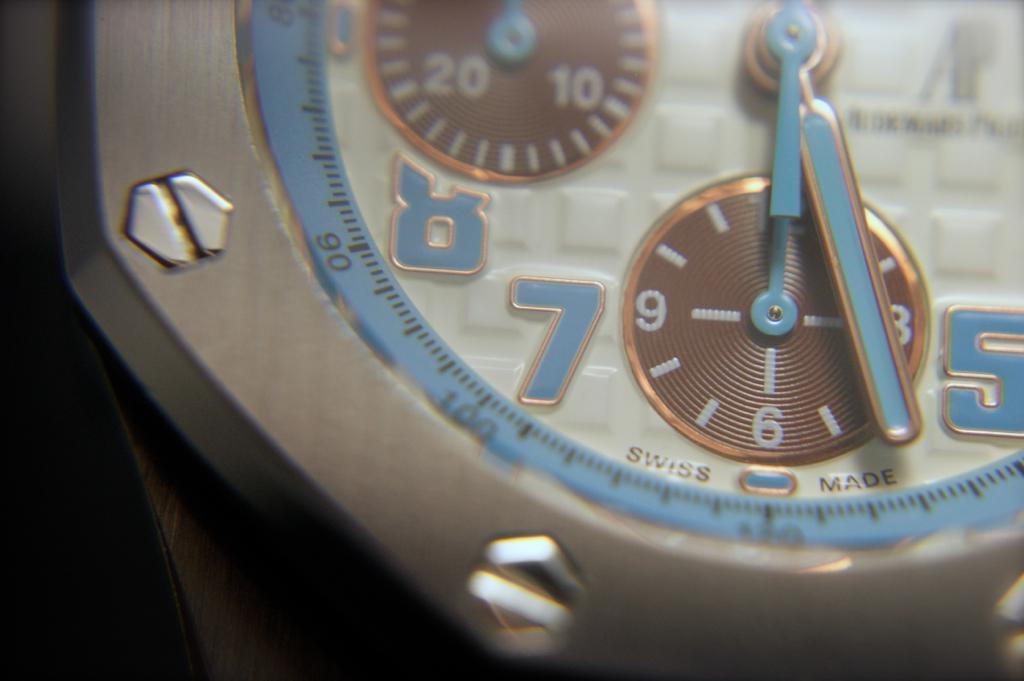In one or two sentences, can you explain what this image depicts? In this image in the front there is a watch. 